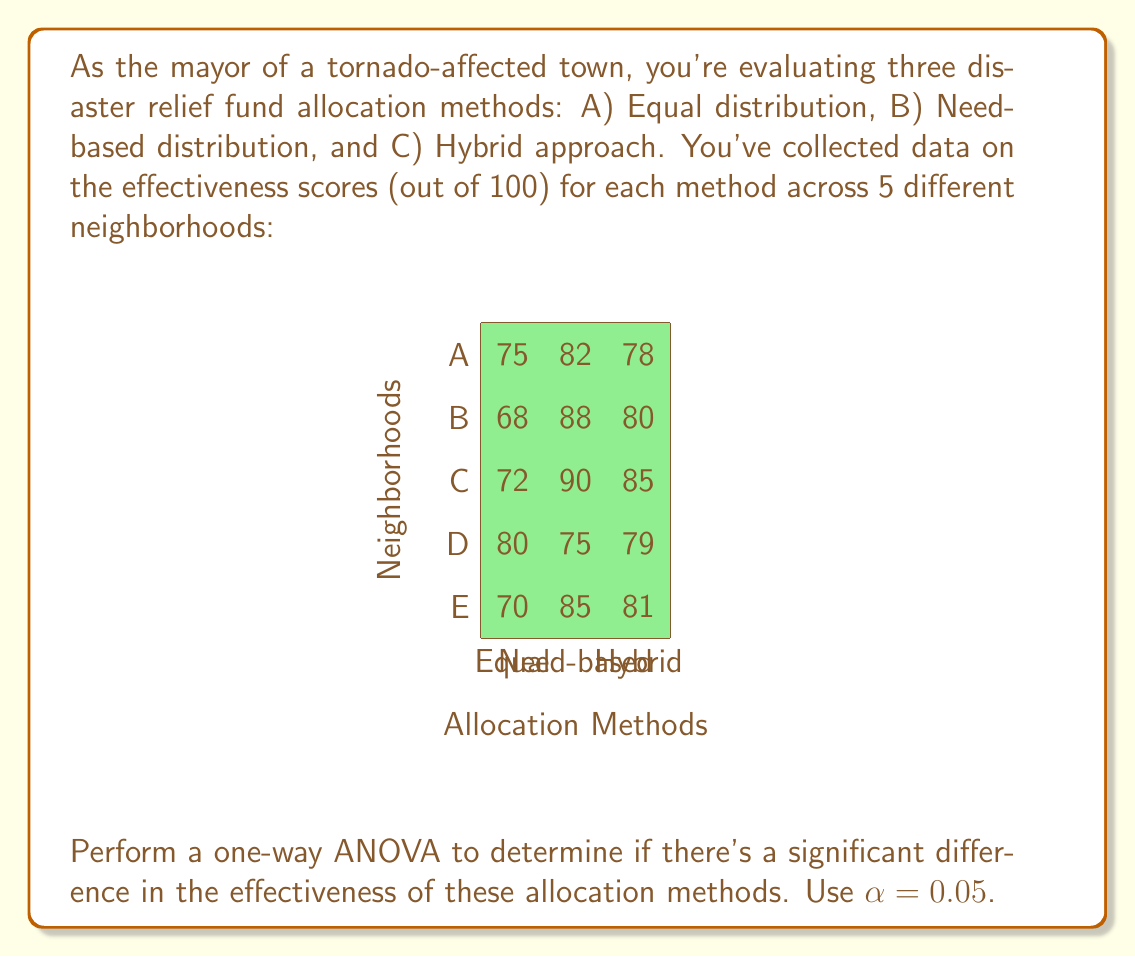Can you solve this math problem? Let's perform the one-way ANOVA step-by-step:

1) First, calculate the total sum of squares (SST):
   $$SST = \sum_{i=1}^{n} (x_i - \bar{x})^2$$
   where $\bar{x}$ is the grand mean.

   Grand mean = $\frac{1335}{15} = 89$

   SST = 990.67

2) Calculate the sum of squares between groups (SSB):
   $$SSB = \sum_{i=1}^{k} n_i(\bar{x}_i - \bar{x})^2$$
   where $k$ is the number of groups, $n_i$ is the size of each group, and $\bar{x}_i$ is the mean of each group.

   Mean of Equal: 73
   Mean of Need-based: 84
   Mean of Hybrid: 80.6

   SSB = 5(73 - 89)^2 + 5(84 - 89)^2 + 5(80.6 - 89)^2 = 361.33

3) Calculate the sum of squares within groups (SSW):
   $$SSW = SST - SSB = 990.67 - 361.33 = 629.33$$

4) Calculate degrees of freedom:
   df(between) = k - 1 = 2
   df(within) = n - k = 12
   df(total) = n - 1 = 14

5) Calculate mean squares:
   $$MS_B = \frac{SSB}{df_B} = \frac{361.33}{2} = 180.67$$
   $$MS_W = \frac{SSW}{df_W} = \frac{629.33}{12} = 52.44$$

6) Calculate F-statistic:
   $$F = \frac{MS_B}{MS_W} = \frac{180.67}{52.44} = 3.45$$

7) Find the critical F-value:
   F_critical (2, 12) at α = 0.05 is approximately 3.89

8) Compare F-statistic to F-critical:
   Since 3.45 < 3.89, we fail to reject the null hypothesis.
Answer: F(2,12) = 3.45, p > 0.05. No significant difference in effectiveness between allocation methods. 